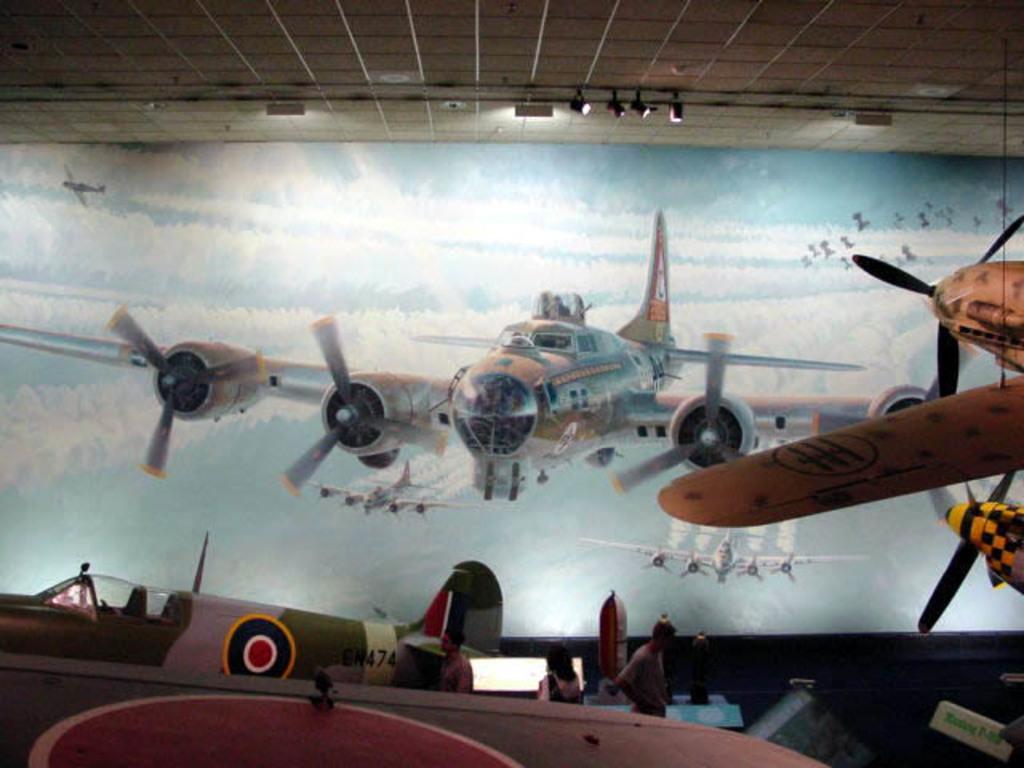Please provide a concise description of this image. In this image there are a few people walking. Around them there are jet planes. There is a screen in front of the woman. In the background of the image there is a poster on the wall. On top of the image there are focus lights. 